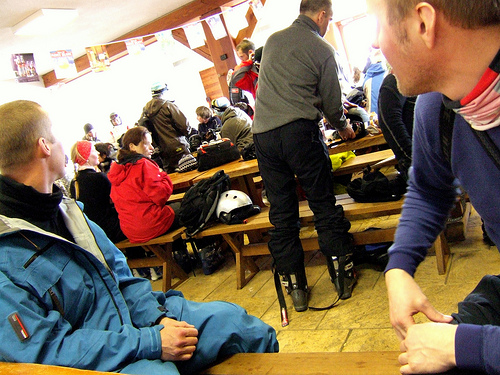<image>
Is the man to the left of the man? Yes. From this viewpoint, the man is positioned to the left side relative to the man. Is the bag above the helmet? No. The bag is not positioned above the helmet. The vertical arrangement shows a different relationship. 